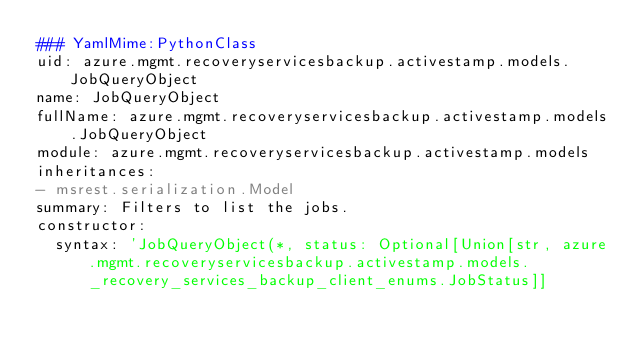Convert code to text. <code><loc_0><loc_0><loc_500><loc_500><_YAML_>### YamlMime:PythonClass
uid: azure.mgmt.recoveryservicesbackup.activestamp.models.JobQueryObject
name: JobQueryObject
fullName: azure.mgmt.recoveryservicesbackup.activestamp.models.JobQueryObject
module: azure.mgmt.recoveryservicesbackup.activestamp.models
inheritances:
- msrest.serialization.Model
summary: Filters to list the jobs.
constructor:
  syntax: 'JobQueryObject(*, status: Optional[Union[str, azure.mgmt.recoveryservicesbackup.activestamp.models._recovery_services_backup_client_enums.JobStatus]]</code> 